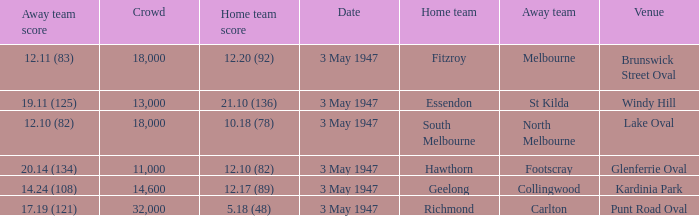Which venue did the away team score 12.10 (82)? Lake Oval. 